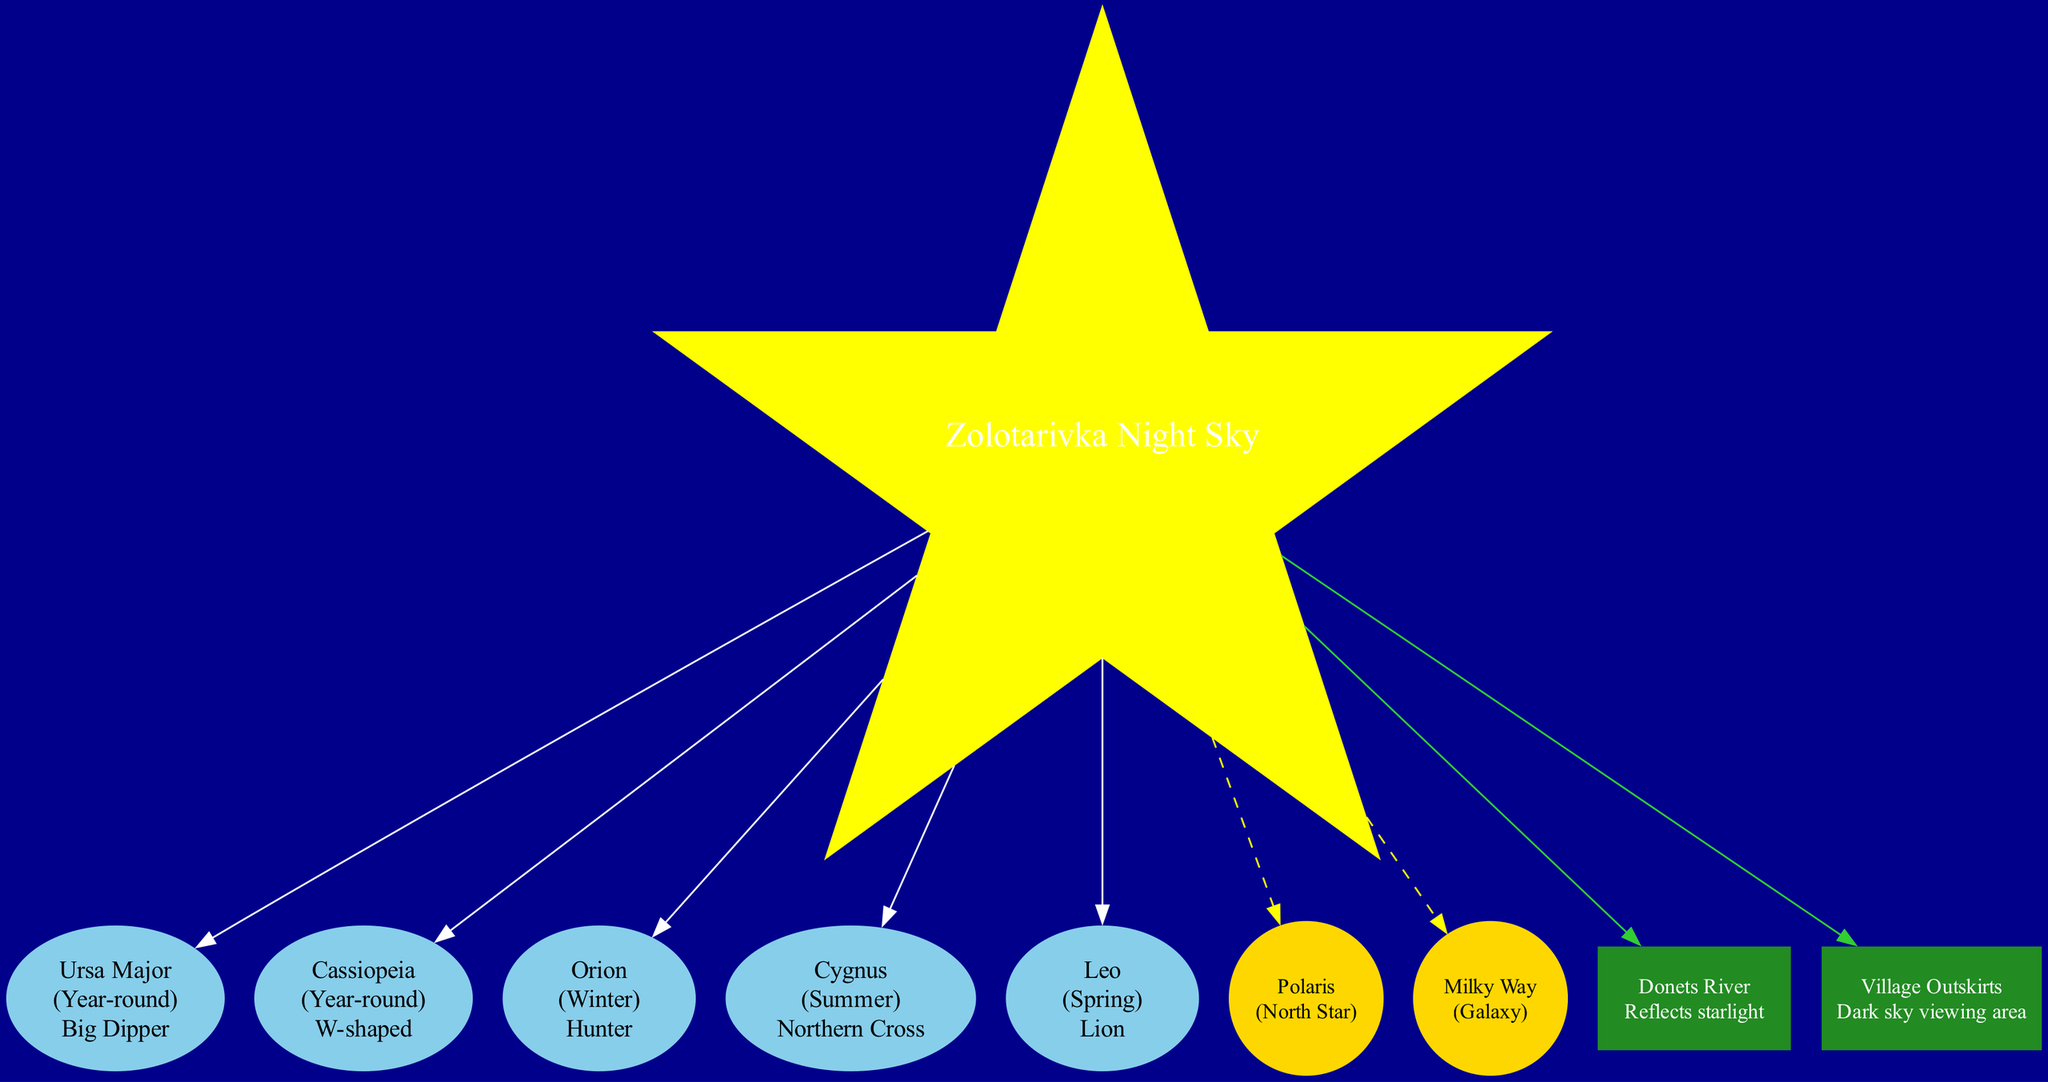What constellations are visible year-round? The diagram displays the constellations under the "constellations" section. The constellations listed as visible year-round are Ursa Major and Cassiopeia.
Answer: Ursa Major, Cassiopeia How many constellations are shown in the diagram? The diagram lists five constellations: Ursa Major, Cassiopeia, Orion, Cygnus, and Leo. Thus, counting them gives a total of five.
Answer: 5 Which constellation represents the Hunter? In the constellation section of the diagram, it shows that Orion is described as the Hunter. Thus, that is the answer.
Answer: Orion What celestial object is best visible in summer? According to the celestial objects section, the Milky Way is noted to be best visible in summer, which directly answers the question.
Answer: Milky Way Where is the North Star located? The location of Polaris, the North Star, is specified in the celestial objects section, indicating it is near Ursa Minor.
Answer: Near Ursa Minor Which local feature reflects starlight? In the local features section, it states that the Donets River reflects starlight, making it the answer to this question.
Answer: Donets River Which constellation can be seen in winter? The diagram identifies Orion as the constellation visible during winter, as listed in the constellations section.
Answer: Orion How many local features are mentioned in the diagram? The local features section of the diagram lists two features: Donets River and Village Outskirts. Counting these gives a total of two local features.
Answer: 2 What is the shape of the celestial objects in the diagram? The diagram notes that celestial objects are represented as circles, indicated in the style attributes for these nodes.
Answer: Circle 